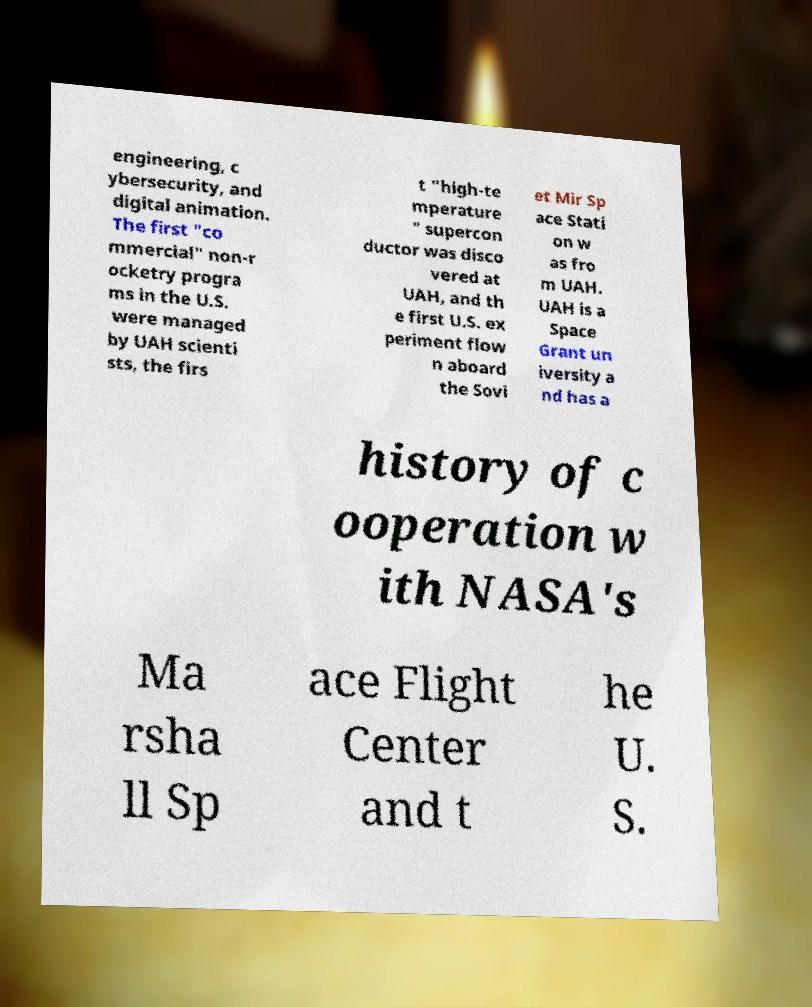Please read and relay the text visible in this image. What does it say? engineering, c ybersecurity, and digital animation. The first "co mmercial" non-r ocketry progra ms in the U.S. were managed by UAH scienti sts, the firs t "high-te mperature " supercon ductor was disco vered at UAH, and th e first U.S. ex periment flow n aboard the Sovi et Mir Sp ace Stati on w as fro m UAH. UAH is a Space Grant un iversity a nd has a history of c ooperation w ith NASA's Ma rsha ll Sp ace Flight Center and t he U. S. 